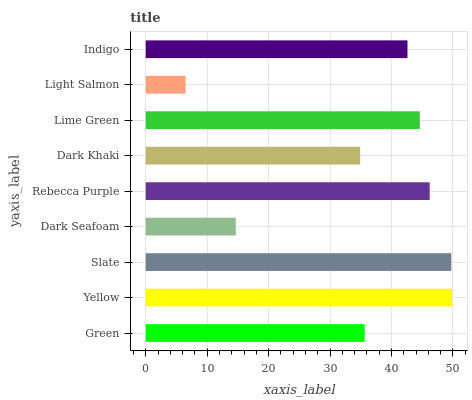Is Light Salmon the minimum?
Answer yes or no. Yes. Is Yellow the maximum?
Answer yes or no. Yes. Is Slate the minimum?
Answer yes or no. No. Is Slate the maximum?
Answer yes or no. No. Is Yellow greater than Slate?
Answer yes or no. Yes. Is Slate less than Yellow?
Answer yes or no. Yes. Is Slate greater than Yellow?
Answer yes or no. No. Is Yellow less than Slate?
Answer yes or no. No. Is Indigo the high median?
Answer yes or no. Yes. Is Indigo the low median?
Answer yes or no. Yes. Is Yellow the high median?
Answer yes or no. No. Is Rebecca Purple the low median?
Answer yes or no. No. 